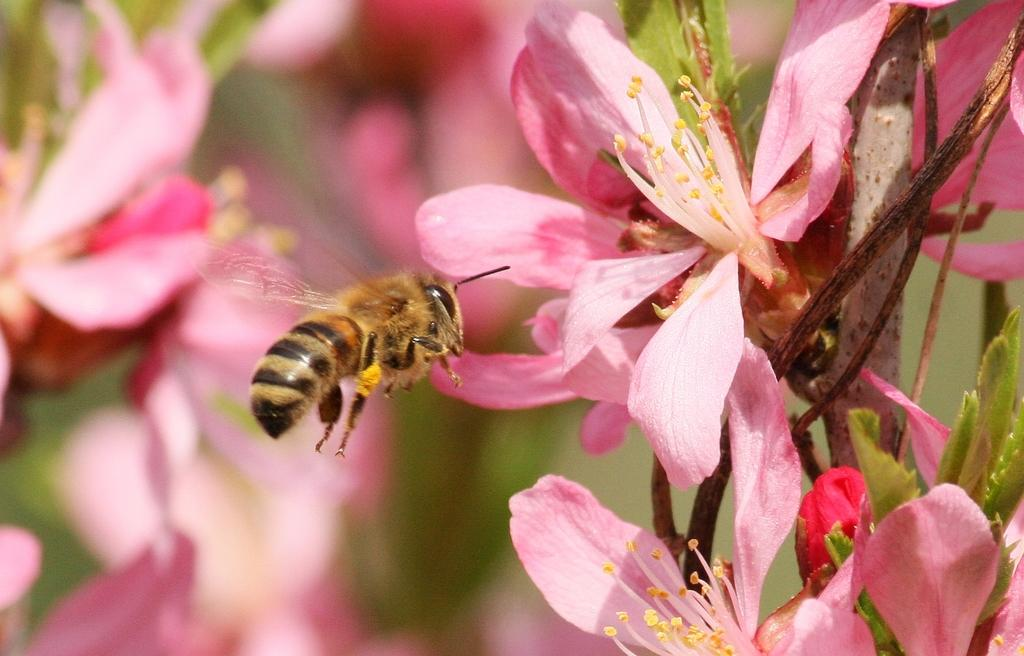What is on the flower in the image? There is an insect on a flower in the image. What can be seen in the background of the image? There are flowers and leaves in the background of the image. What type of skate is being used by the insect in the image? There is no skate present in the image; it features an insect on a flower. 